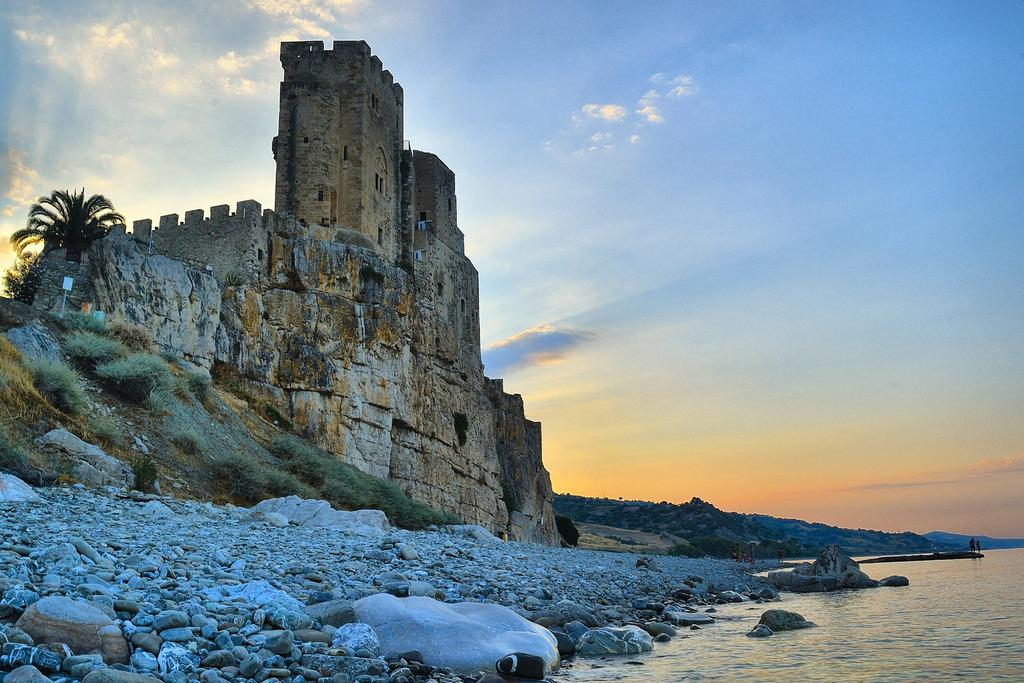What is one of the natural elements present in the image? There is water in the image. What type of geological features can be seen in the image? There are rocks and stones in the image. What type of vegetation is present in the image? There is grass in the image. What type of structure is present in the image? There is a fort in the image. What type of transportation is visible in the image? There is no transportation visible in the image. What type of business is being conducted in the image? There is no business activity depicted in the image. What type of trail can be seen in the image? There is no trail present in the image. Is the queen visible in the image? There is no queen present in the image. 